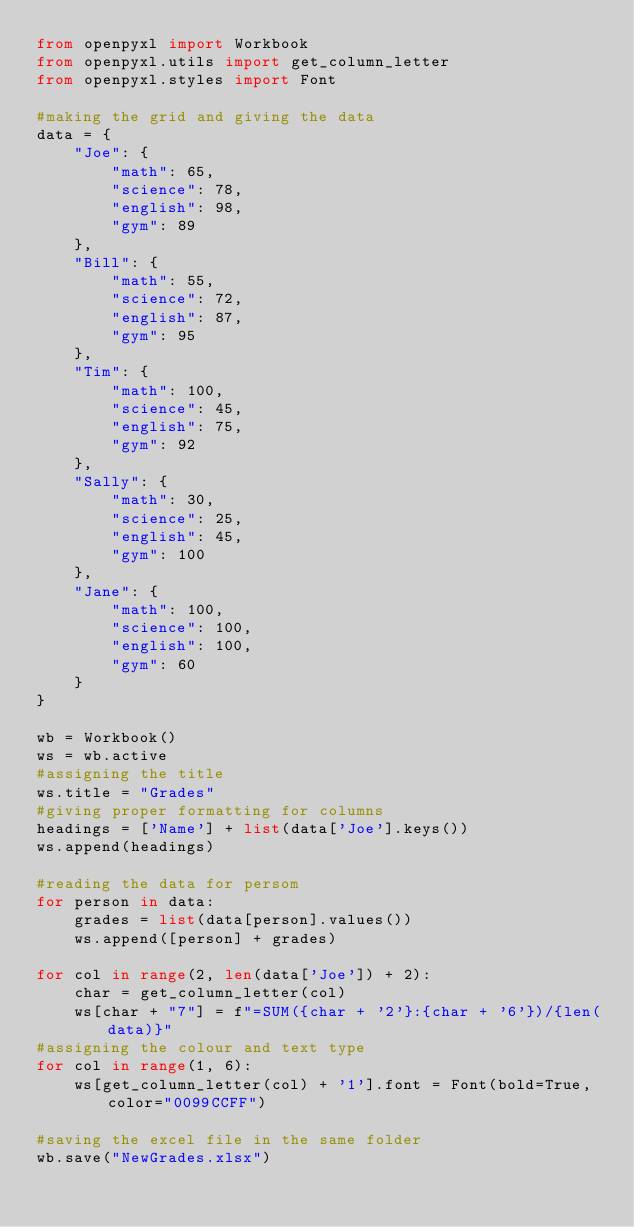Convert code to text. <code><loc_0><loc_0><loc_500><loc_500><_Python_>from openpyxl import Workbook
from openpyxl.utils import get_column_letter
from openpyxl.styles import Font

#making the grid and giving the data
data = {
	"Joe": {
		"math": 65,
		"science": 78,
		"english": 98,
		"gym": 89
	},
	"Bill": {
		"math": 55,
		"science": 72,
		"english": 87,
		"gym": 95
	},
	"Tim": {
		"math": 100,
		"science": 45,
		"english": 75,
		"gym": 92
	},
	"Sally": {
		"math": 30,
		"science": 25,
		"english": 45,
		"gym": 100
	},
	"Jane": {
		"math": 100,
		"science": 100,
		"english": 100,
		"gym": 60
	}
}

wb = Workbook()
ws = wb.active
#assigning the title
ws.title = "Grades"
#giving proper formatting for columns 
headings = ['Name'] + list(data['Joe'].keys())
ws.append(headings)

#reading the data for persom
for person in data:
	grades = list(data[person].values())
	ws.append([person] + grades)

for col in range(2, len(data['Joe']) + 2):
	char = get_column_letter(col)
	ws[char + "7"] = f"=SUM({char + '2'}:{char + '6'})/{len(data)}"
#assigning the colour and text type 
for col in range(1, 6):
	ws[get_column_letter(col) + '1'].font = Font(bold=True, color="0099CCFF")

#saving the excel file in the same folder
wb.save("NewGrades.xlsx")
</code> 